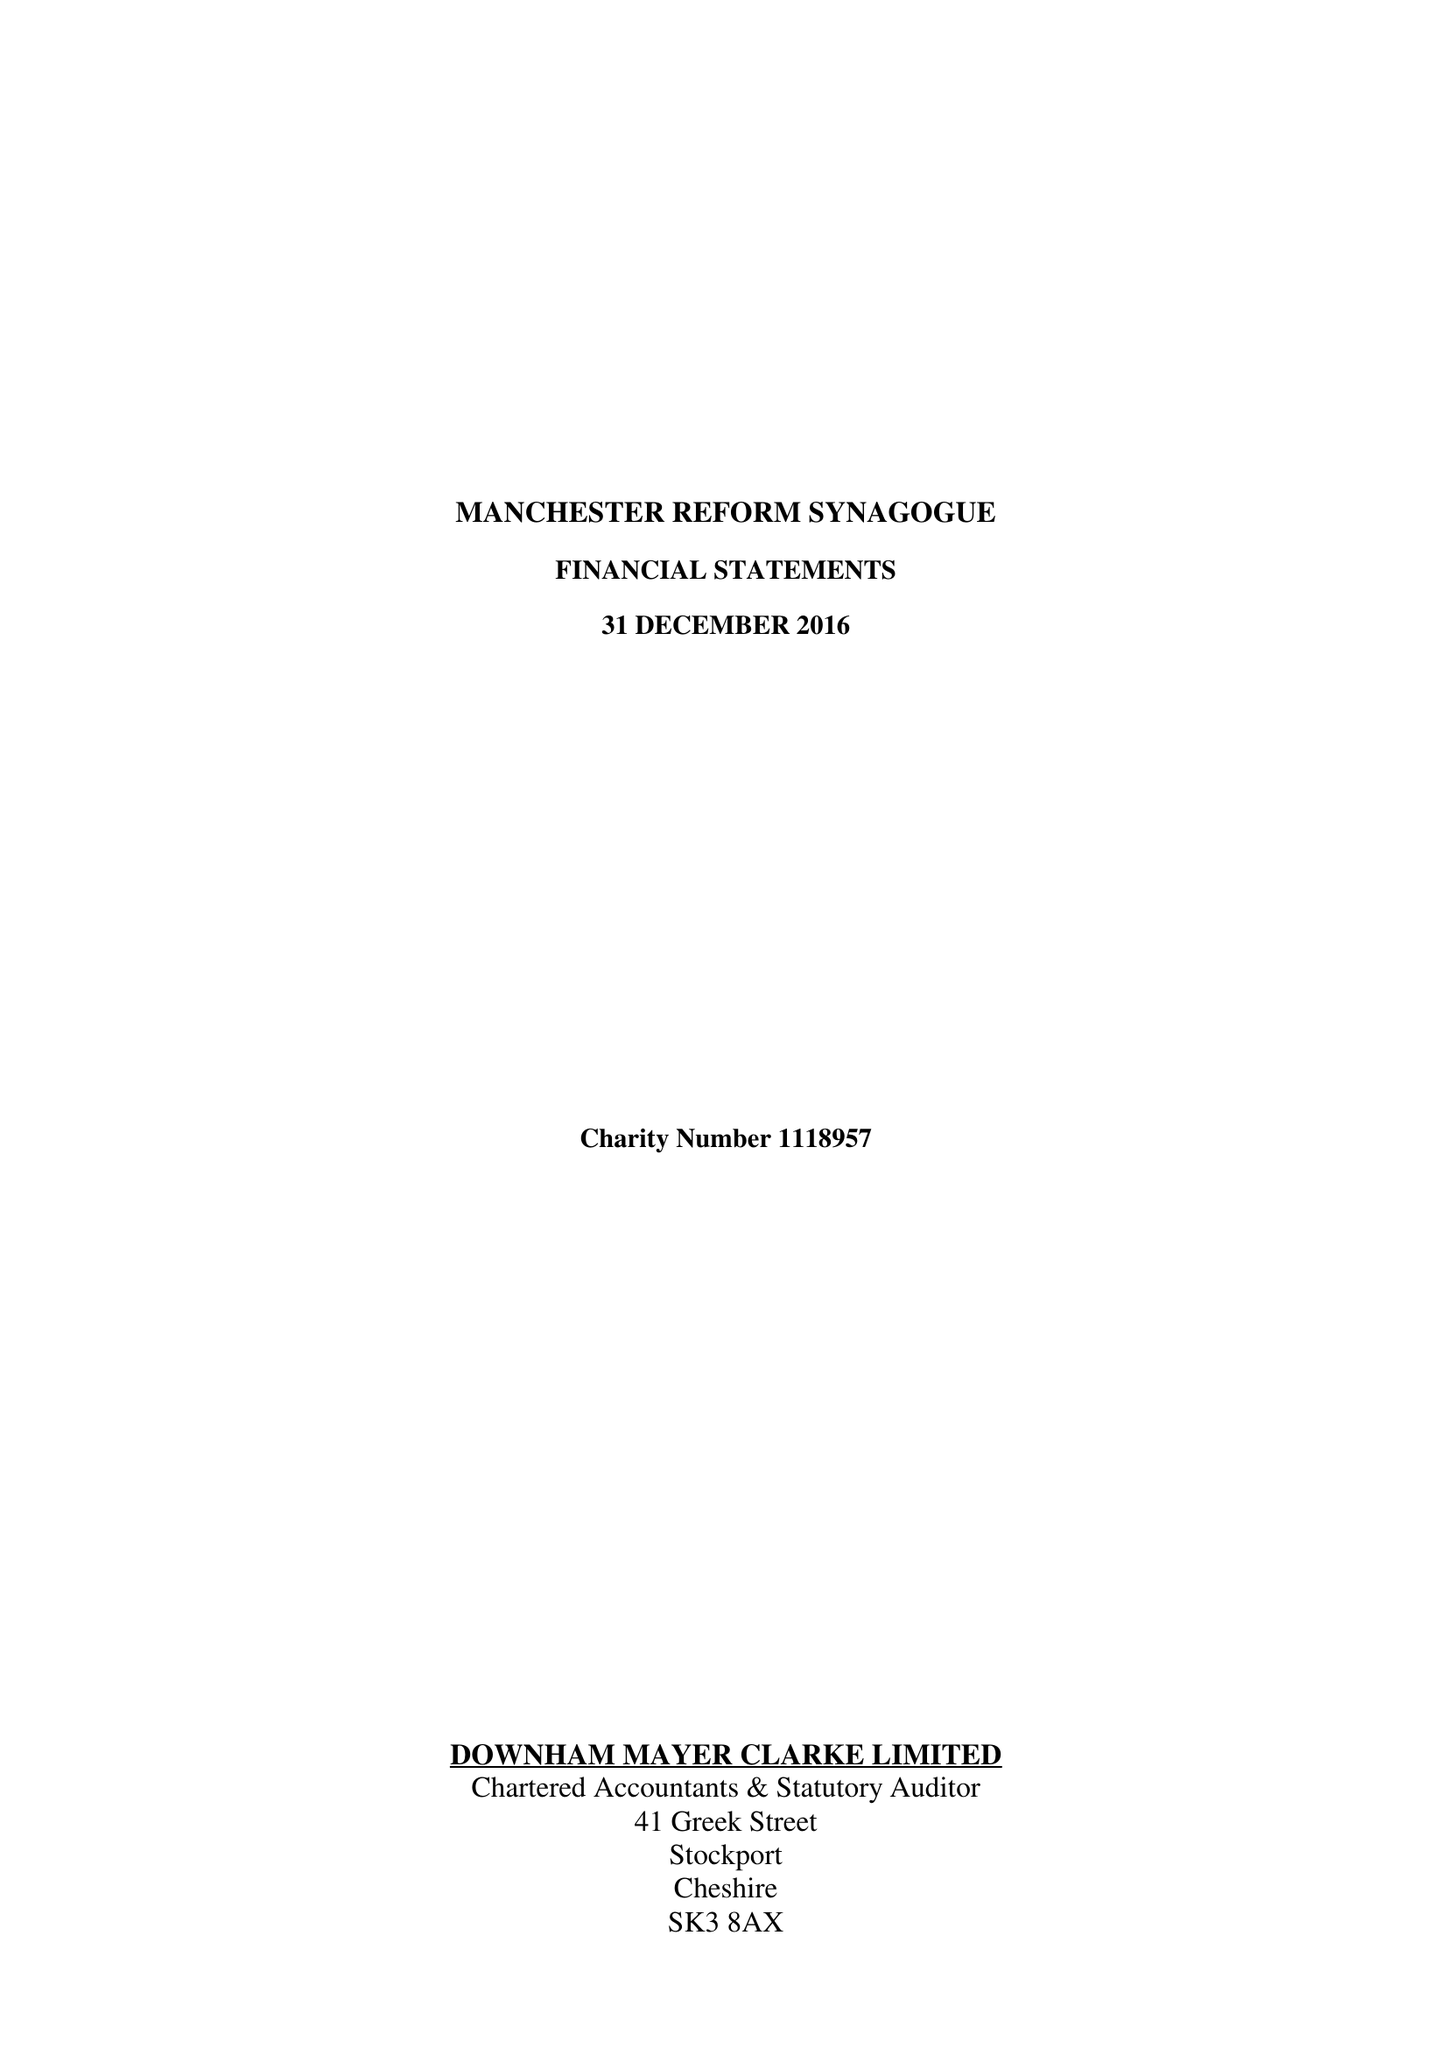What is the value for the charity_number?
Answer the question using a single word or phrase. 1118957 